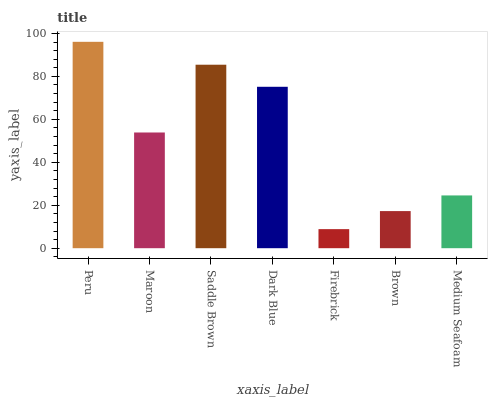Is Firebrick the minimum?
Answer yes or no. Yes. Is Peru the maximum?
Answer yes or no. Yes. Is Maroon the minimum?
Answer yes or no. No. Is Maroon the maximum?
Answer yes or no. No. Is Peru greater than Maroon?
Answer yes or no. Yes. Is Maroon less than Peru?
Answer yes or no. Yes. Is Maroon greater than Peru?
Answer yes or no. No. Is Peru less than Maroon?
Answer yes or no. No. Is Maroon the high median?
Answer yes or no. Yes. Is Maroon the low median?
Answer yes or no. Yes. Is Dark Blue the high median?
Answer yes or no. No. Is Dark Blue the low median?
Answer yes or no. No. 